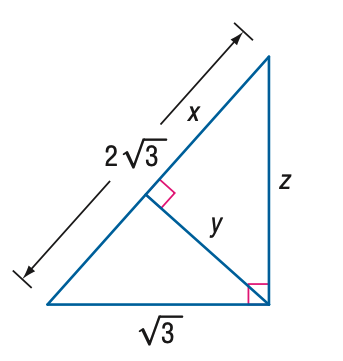Answer the mathemtical geometry problem and directly provide the correct option letter.
Question: Find x.
Choices: A: \frac { 3 } { 2 } \sqrt { 2 } B: \frac { 3 } { 2 } \sqrt { 3 } C: 3 \sqrt { 2 } D: 3 \sqrt { 3 } B 